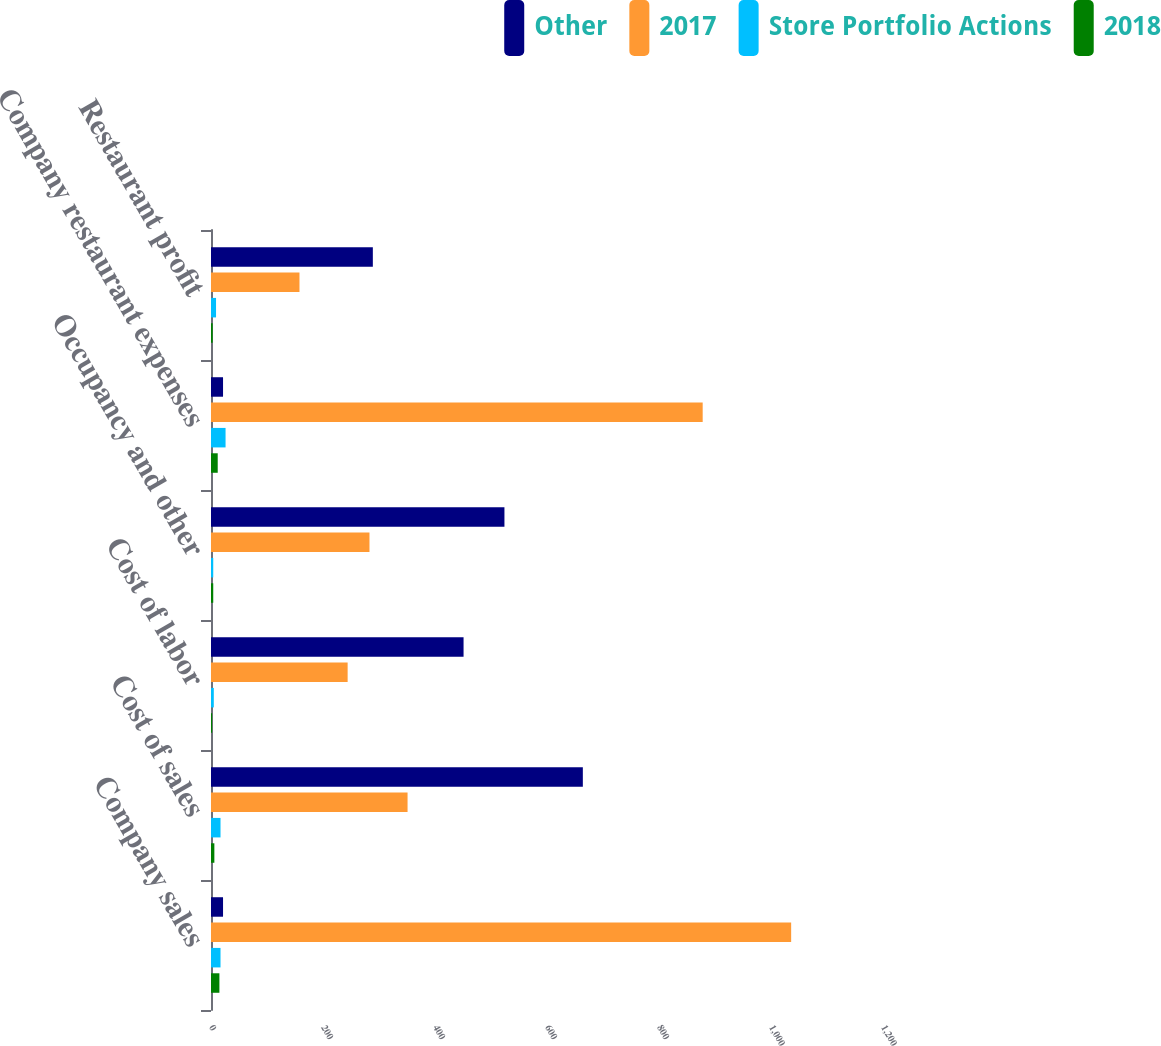Convert chart. <chart><loc_0><loc_0><loc_500><loc_500><stacked_bar_chart><ecel><fcel>Company sales<fcel>Cost of sales<fcel>Cost of labor<fcel>Occupancy and other<fcel>Company restaurant expenses<fcel>Restaurant profit<nl><fcel>Other<fcel>21.5<fcel>664<fcel>451<fcel>524<fcel>21.5<fcel>289<nl><fcel>2017<fcel>1036<fcel>351<fcel>244<fcel>283<fcel>878<fcel>158<nl><fcel>Store Portfolio Actions<fcel>17<fcel>17<fcel>5<fcel>4<fcel>26<fcel>9<nl><fcel>2018<fcel>15<fcel>6<fcel>2<fcel>4<fcel>12<fcel>3<nl></chart> 